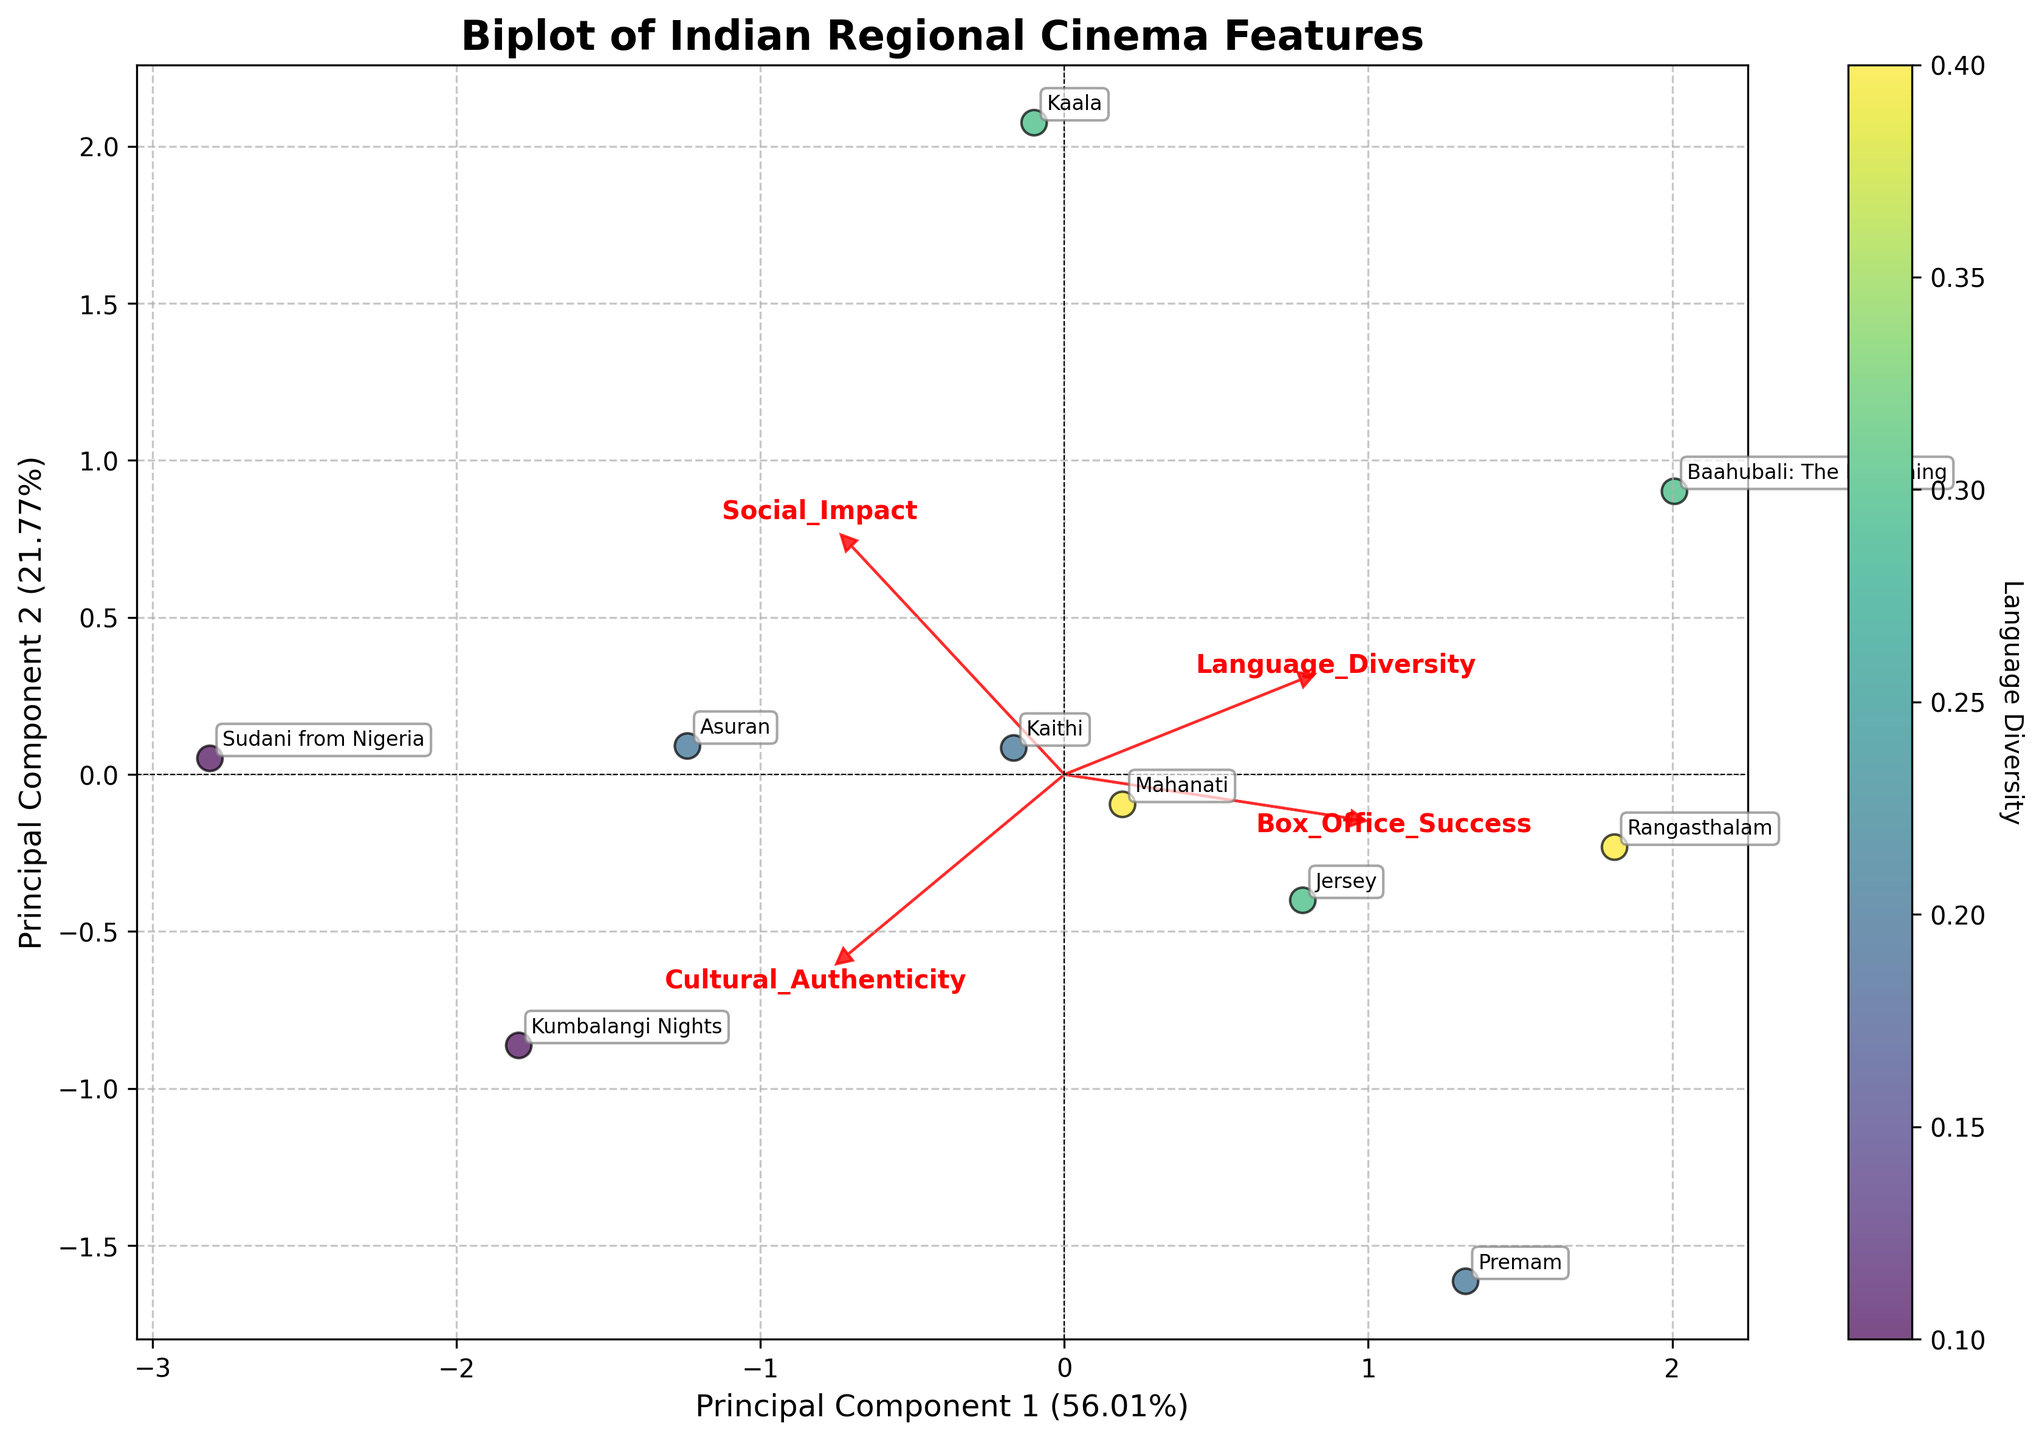What is the title of the plot? The title of the plot is displayed at the top and provides a summary of the figure's content. In this case, it is "Biplot of Indian Regional Cinema Features."
Answer: Biplot of Indian Regional Cinema Features Which film is located furthest to the right along the x-axis (Principal Component 1)? To determine which film is furthest to the right, find the film with the highest value along the x-axis. The film in this position is "Rangasthalam."
Answer: Rangasthalam What does the color bar represent? The color bar provides additional information about the data points. In this biplot, it indicates the level of "Language Diversity" for each film, from lower to higher values.
Answer: Language Diversity Which film demonstrates the highest "Social Impact" and where is it positioned in the plot? The film with the highest "Social Impact" can be identified by locating the film positioned near the highest point of the arrow labeled "Social Impact." This film is "Asuran" and it is positioned toward the upper right.
Answer: Asuran Between "Mahanati" and "Jersey," which film is closer to the origin? To determine which film is closer to the origin, compare the distances of both films from the center (0,0). Both the x and y coordinates are closer to zero for "Jersey" compared to "Mahanati."
Answer: Jersey Which feature has the strongest contribution to Principal Component 2? To figure out the feature with the strongest contribution, look at the length and direction of the arrows. The feature with the most substantial positive projection along the y-axis (Principal Component 2) is "Cultural Authenticity."
Answer: Cultural Authenticity Is there a film that scores high in both "Cultural Authenticity" and "Social Impact"? If so, which one? To identify such a film, look for a data point that lies along or close to the direction of both the "Cultural Authenticity" and "Social Impact" arrows. "Kumbalangi Nights" is located in this region.
Answer: Kumbalangi Nights Which films have a high level of "Box Office Success" but might be low on "Language Diversity"? A film with high "Box Office Success" will be closer to the arrow pointing in that direction, but further from the "Language Diversity" arrow. "Baahubali: The Beginning" and "Rangasthalam" fit this description.
Answer: Baahubali: The Beginning and Rangasthalam What is the relationship between "Language Diversity" and Principal Component 1? The "Language Diversity" arrow is aligned more closely along Principal Component 1, but in a relatively neutral direction indicating moderate influence. Thus, it suggests that "Language Diversity" contributes to distinction along Principal Component 1 but not dominantly.
Answer: Moderate positive relationship Which vectors (arrows) seem to be most orthogonal to each other, indicating lack of correlation? To identify orthogonal vectors, look for arrows that form close to a 90-degree angle. The vectors for "Language Diversity" and "Cultural Authenticity" appear to be the most orthogonal, suggesting these features are less correlated.
Answer: Language Diversity and Cultural Authenticity 